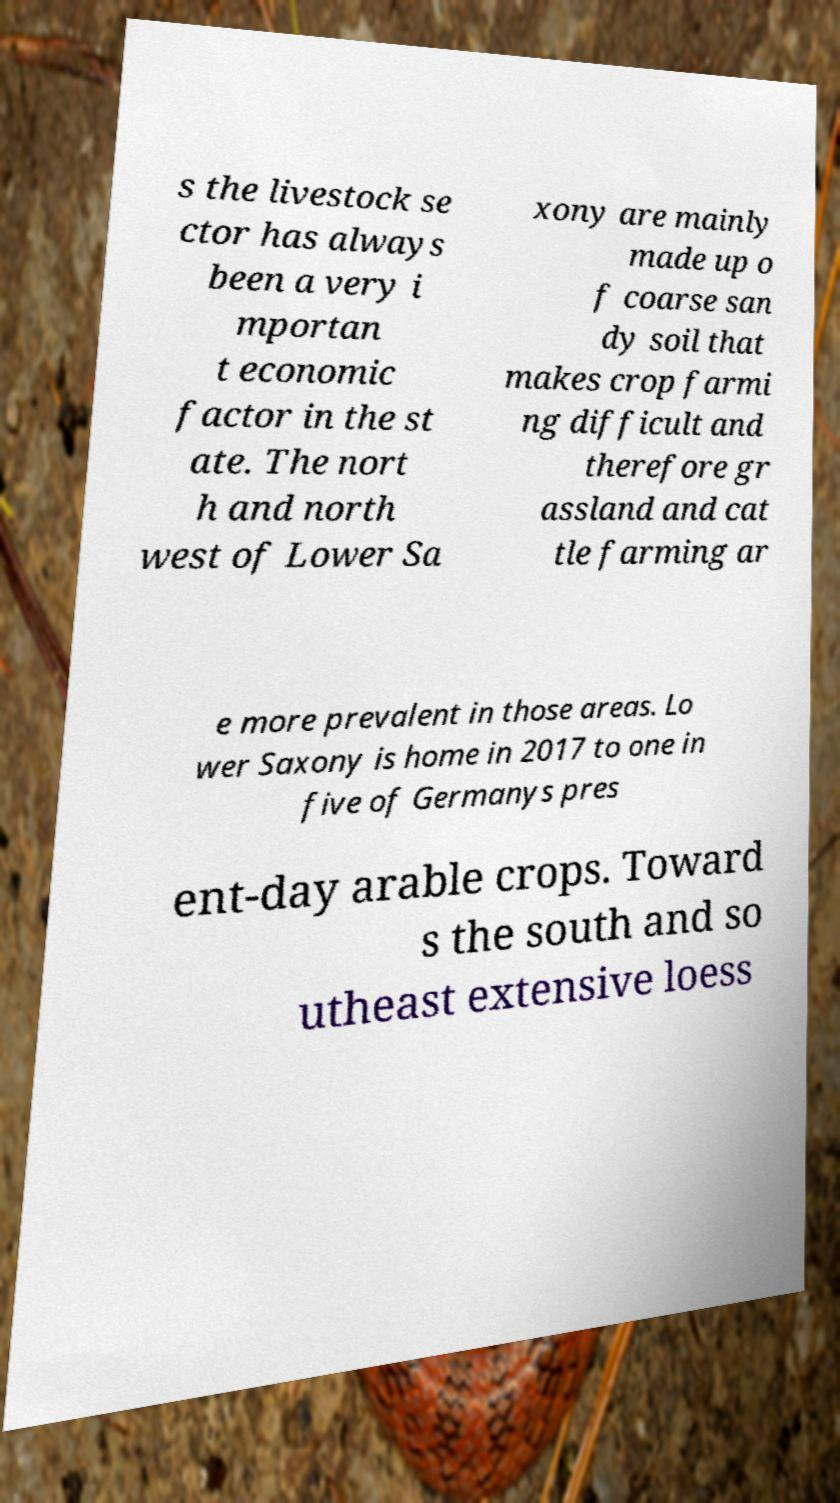There's text embedded in this image that I need extracted. Can you transcribe it verbatim? s the livestock se ctor has always been a very i mportan t economic factor in the st ate. The nort h and north west of Lower Sa xony are mainly made up o f coarse san dy soil that makes crop farmi ng difficult and therefore gr assland and cat tle farming ar e more prevalent in those areas. Lo wer Saxony is home in 2017 to one in five of Germanys pres ent-day arable crops. Toward s the south and so utheast extensive loess 